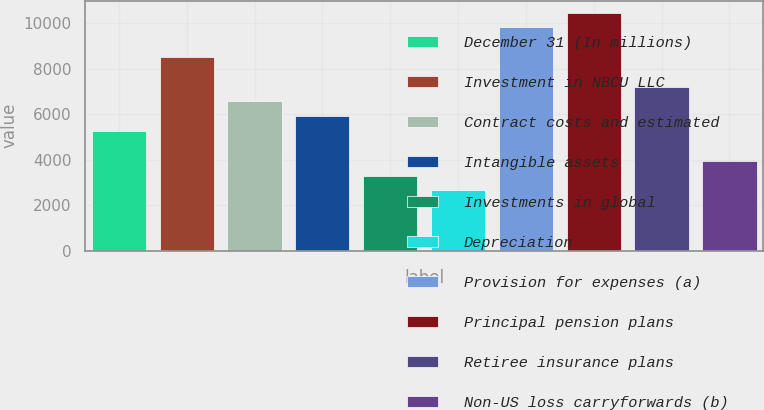Convert chart. <chart><loc_0><loc_0><loc_500><loc_500><bar_chart><fcel>December 31 (In millions)<fcel>Investment in NBCU LLC<fcel>Contract costs and estimated<fcel>Intangible assets<fcel>Investments in global<fcel>Depreciation<fcel>Provision for expenses (a)<fcel>Principal pension plans<fcel>Retiree insurance plans<fcel>Non-US loss carryforwards (b)<nl><fcel>5262.8<fcel>8523.3<fcel>6567<fcel>5914.9<fcel>3306.5<fcel>2654.4<fcel>9827.5<fcel>10479.6<fcel>7219.1<fcel>3958.6<nl></chart> 